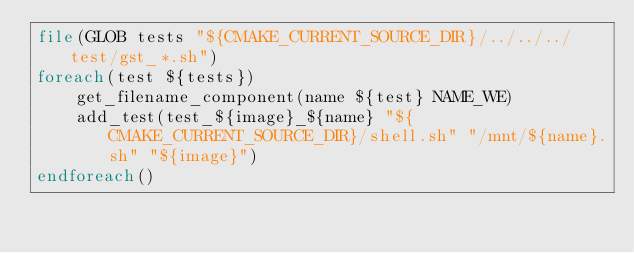Convert code to text. <code><loc_0><loc_0><loc_500><loc_500><_CMake_>file(GLOB tests "${CMAKE_CURRENT_SOURCE_DIR}/../../../test/gst_*.sh")
foreach(test ${tests})
    get_filename_component(name ${test} NAME_WE)
    add_test(test_${image}_${name} "${CMAKE_CURRENT_SOURCE_DIR}/shell.sh" "/mnt/${name}.sh" "${image}")
endforeach()
</code> 